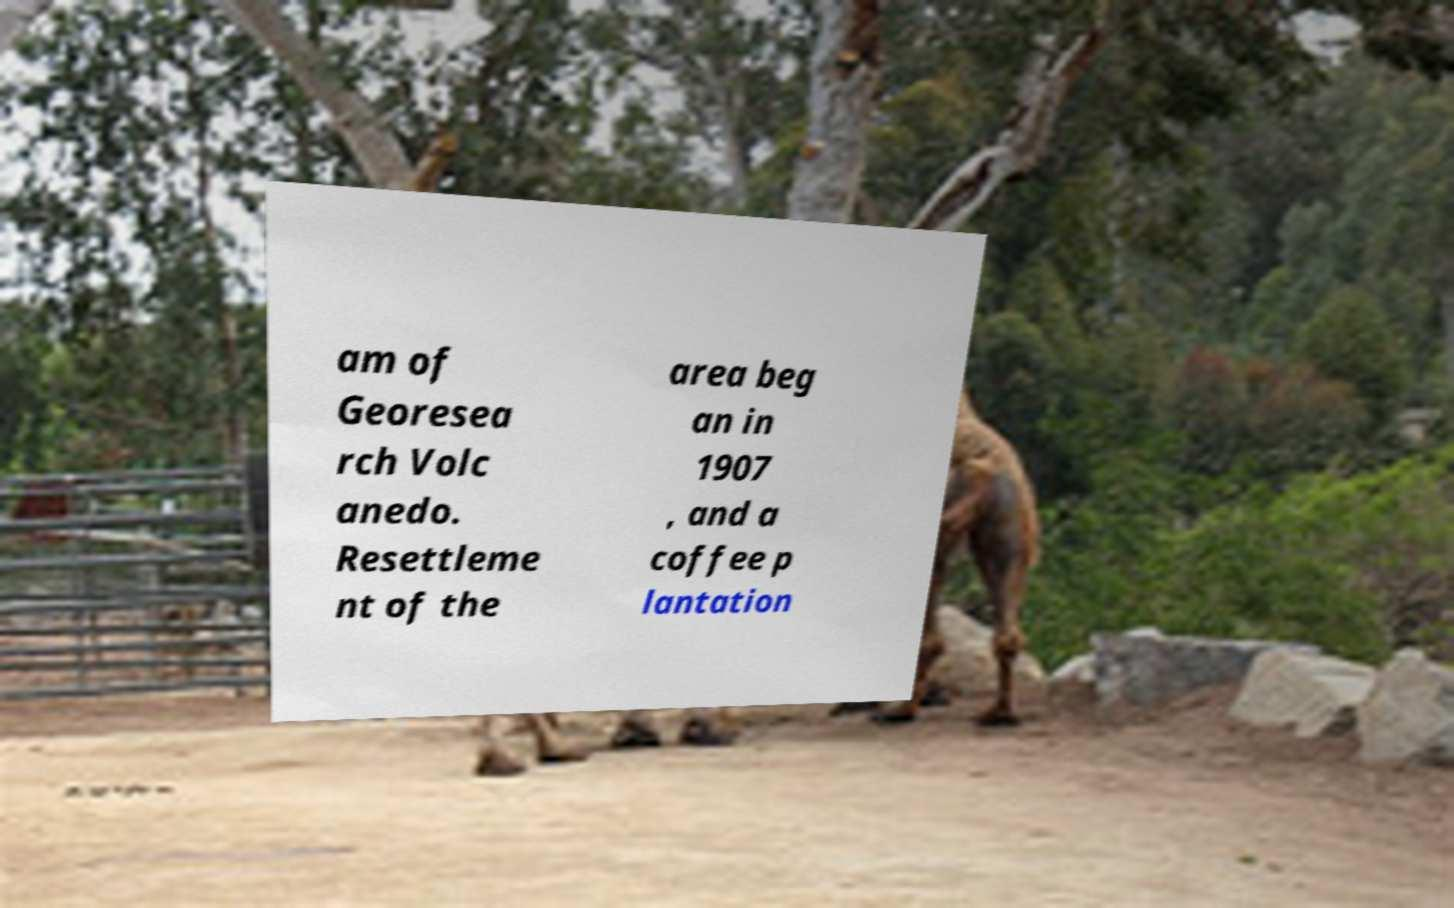For documentation purposes, I need the text within this image transcribed. Could you provide that? am of Georesea rch Volc anedo. Resettleme nt of the area beg an in 1907 , and a coffee p lantation 